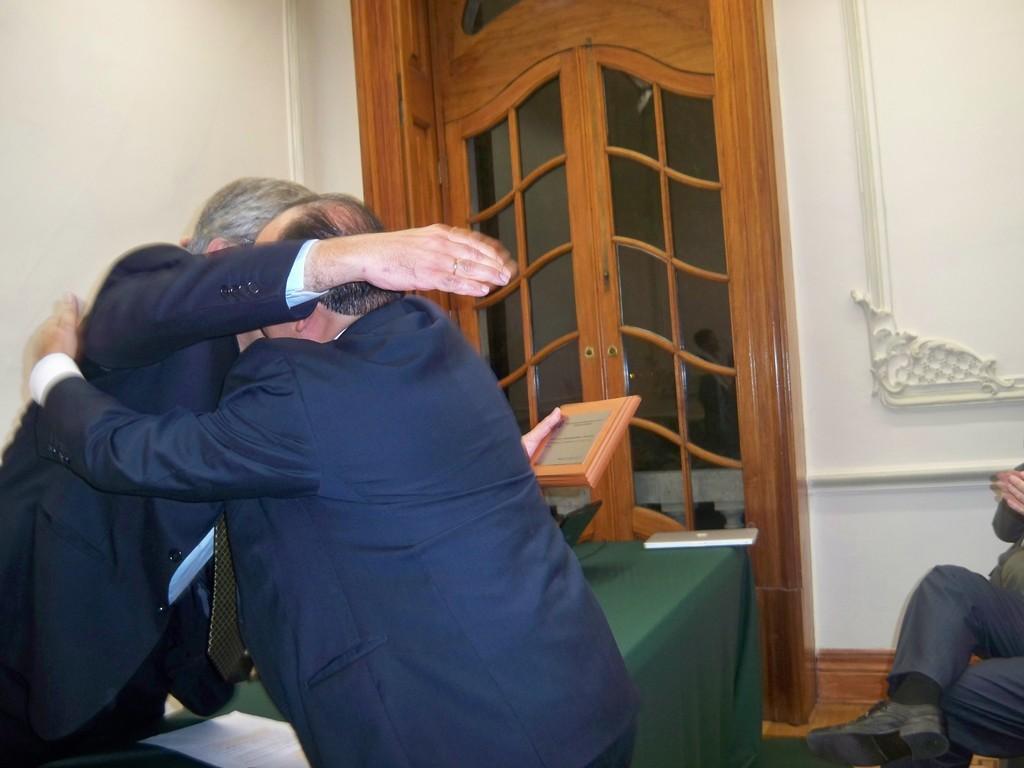Can you describe this image briefly? In the image in the center we can see two persons were standing and one person is holding frame. In the background there is a wall,door,tablecloth,paper,laptop and one person is sitting. 